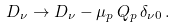Convert formula to latex. <formula><loc_0><loc_0><loc_500><loc_500>D _ { \nu } \rightarrow D _ { \nu } - \mu _ { p } \, Q _ { p } \, \delta _ { \nu 0 } \, .</formula> 